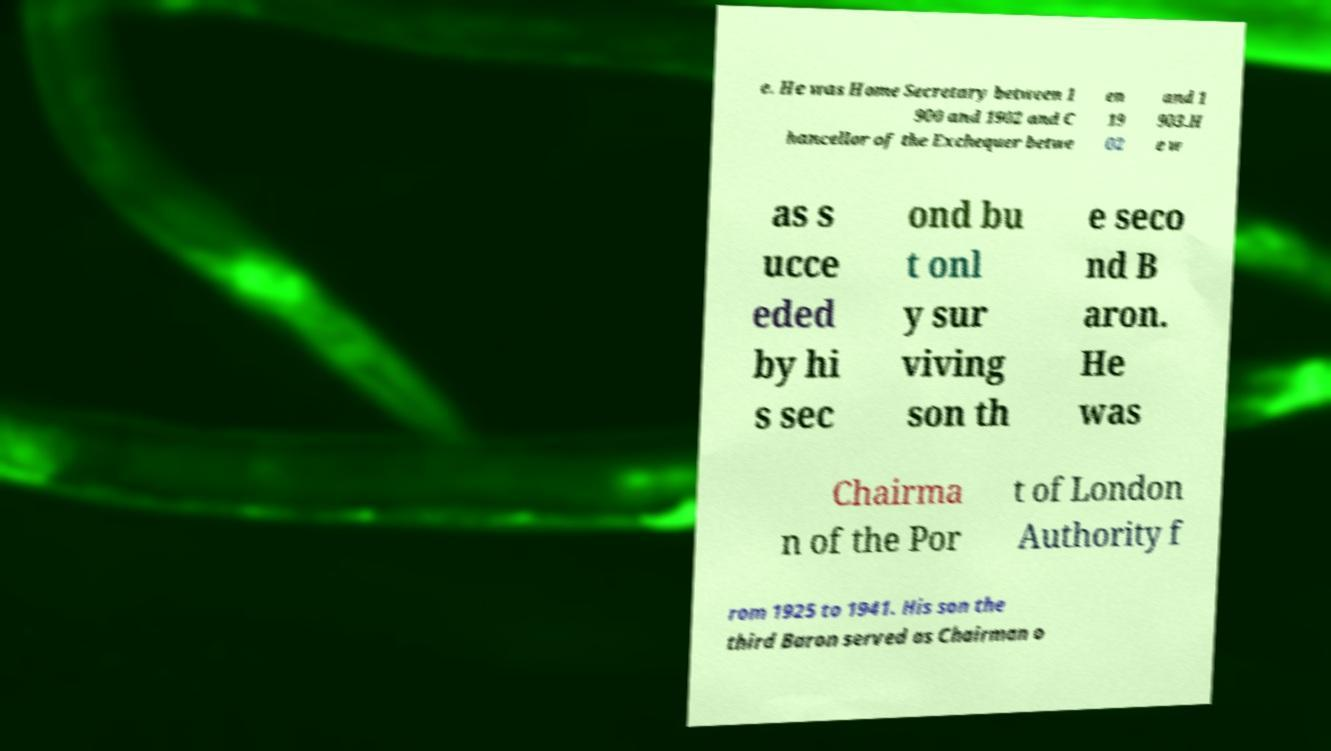I need the written content from this picture converted into text. Can you do that? e. He was Home Secretary between 1 900 and 1902 and C hancellor of the Exchequer betwe en 19 02 and 1 903.H e w as s ucce eded by hi s sec ond bu t onl y sur viving son th e seco nd B aron. He was Chairma n of the Por t of London Authority f rom 1925 to 1941. His son the third Baron served as Chairman o 